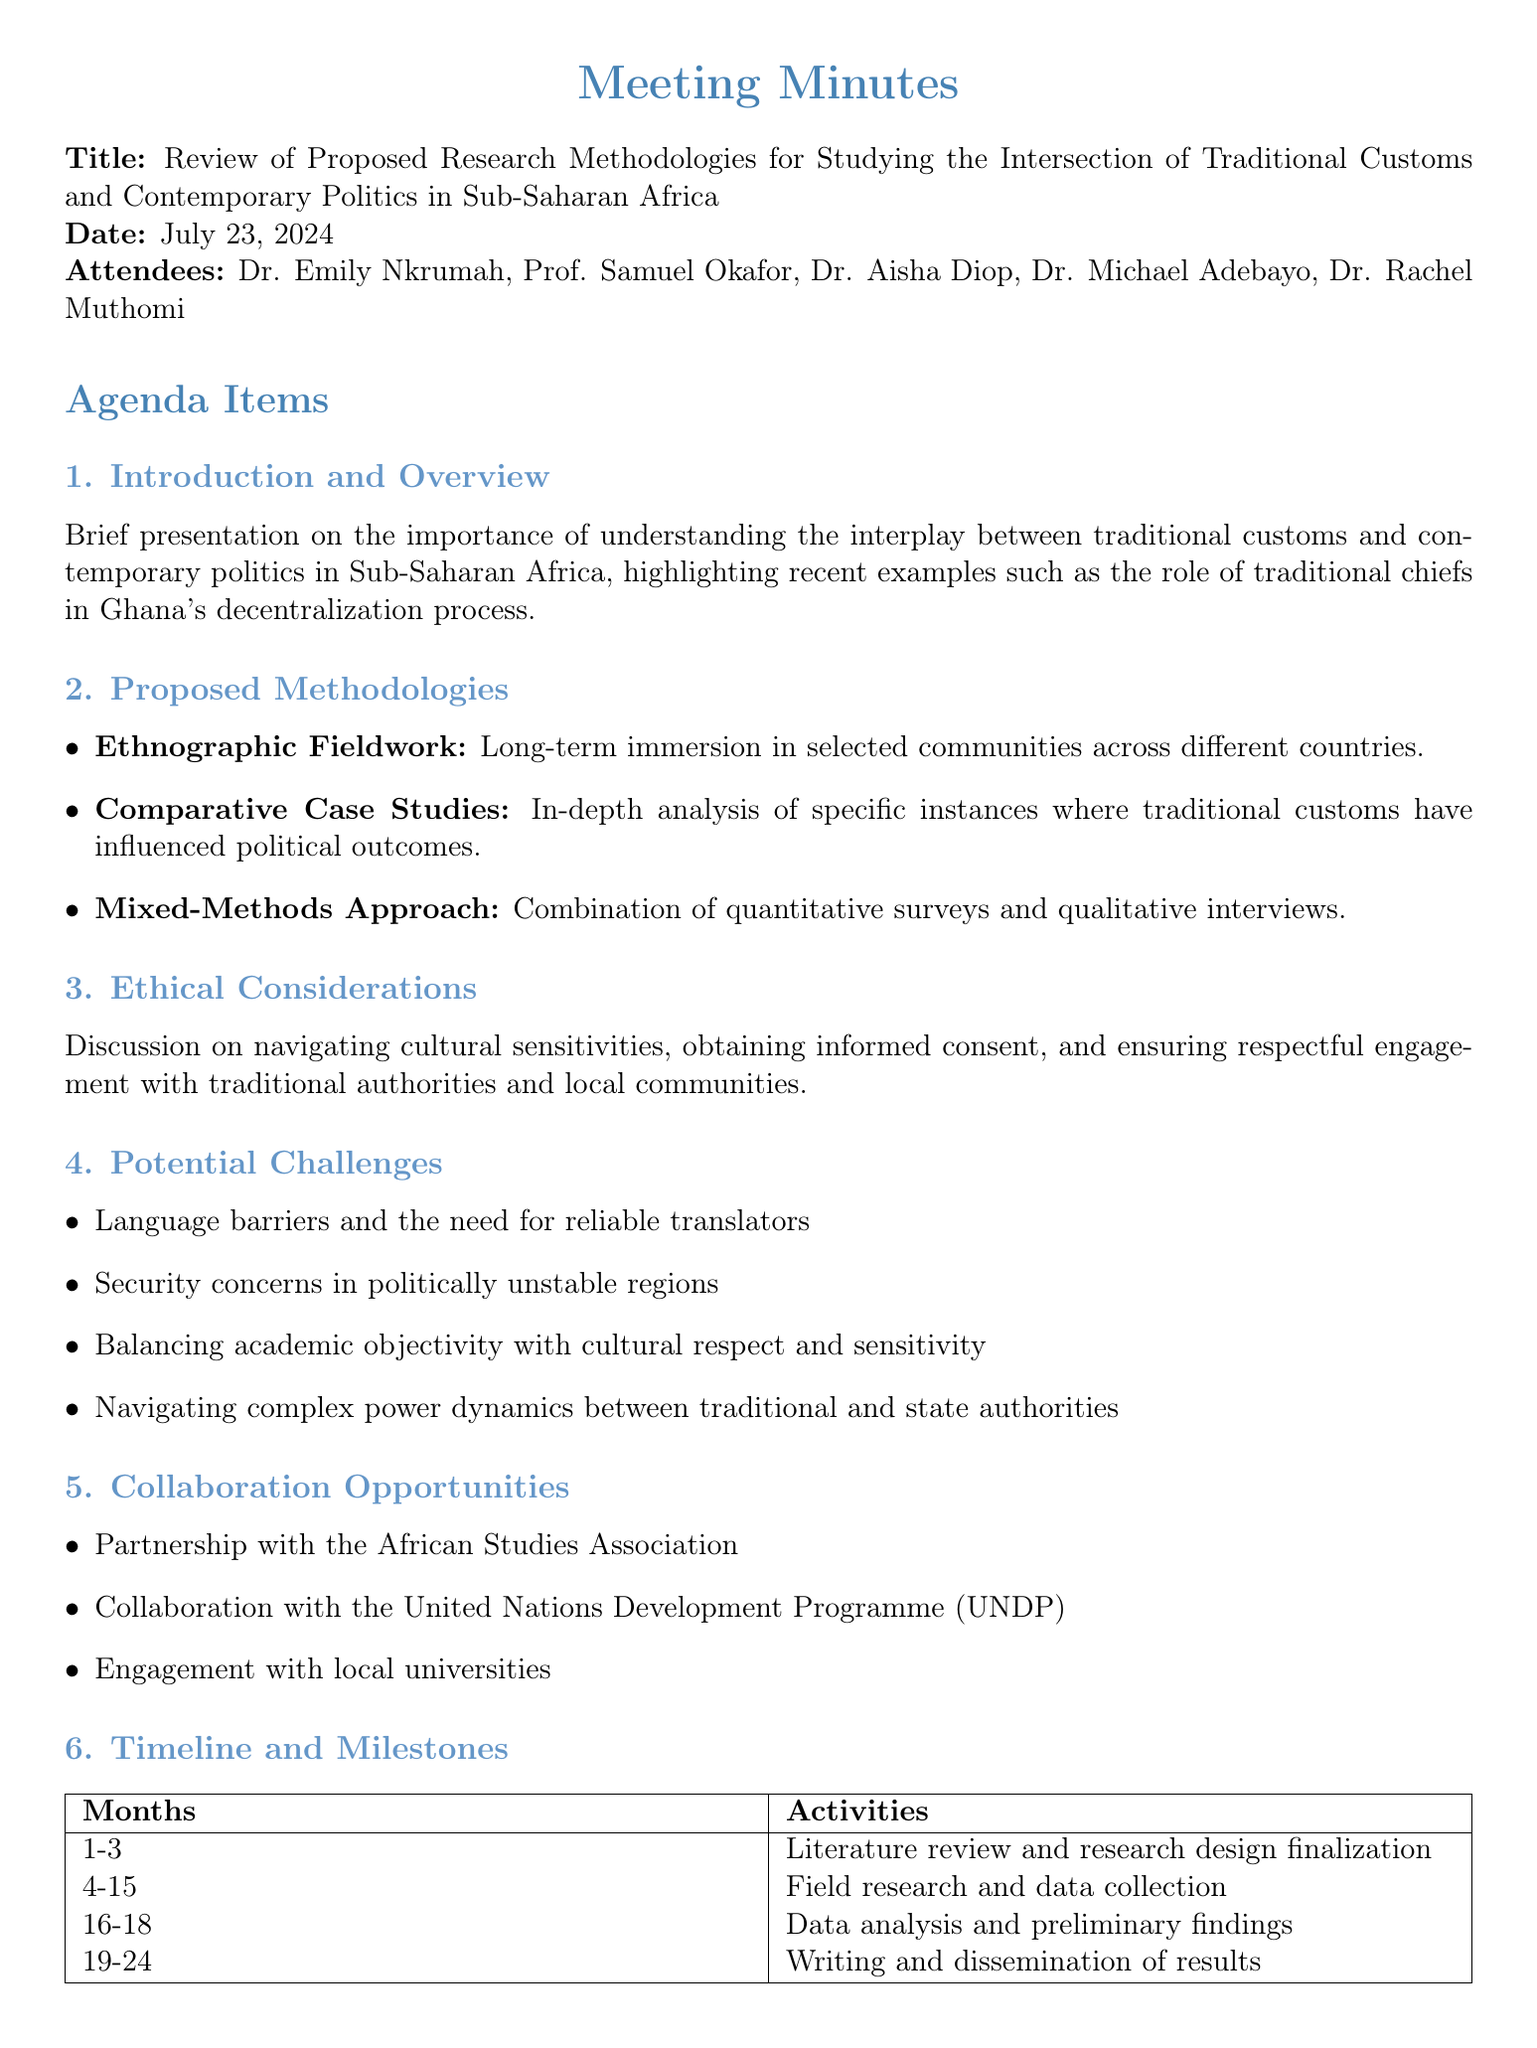What is the title of the meeting? The title of the meeting is given in the document as "Review of Proposed Research Methodologies for Studying the Intersection of Traditional Customs and Contemporary Politics in Sub-Saharan Africa."
Answer: Review of Proposed Research Methodologies for Studying the Intersection of Traditional Customs and Contemporary Politics in Sub-Saharan Africa Who are the attendees? The names of the attendees are listed in the document.
Answer: Dr. Emily Nkrumah, Prof. Samuel Okafor, Dr. Aisha Diop, Dr. Michael Adebayo, Dr. Rachel Muthomi What is the first agenda item? The first agenda item is stated in the document as "Introduction and Overview."
Answer: Introduction and Overview What method allows for detailed examination of specific phenomena? This method is described under Proposed Methodologies and refers to the analysis of specific instances where traditional customs have influenced political outcomes.
Answer: Comparative Case Studies What is one of the potential challenges mentioned? The document lists several challenges under Potential Challenges, and this question seeks a specific example.
Answer: Language barriers and the need for reliable translators What is the expected outcome related to policy recommendations? The document specifies that one expected outcome is to create guidelines for integrating traditional governance structures into modern democratic processes.
Answer: Policy recommendations for integrating traditional governance structures into modern democratic processes When is the next meeting scheduled? The date for the next meeting is clearly stated in the document.
Answer: July 15, 2023 Which action item involves Dr. Aisha Diop? The document details the action items assigned to each attendee, including Dr. Aisha Diop's task.
Answer: To draft the ethics approval application for submission to the Institutional Review Board 